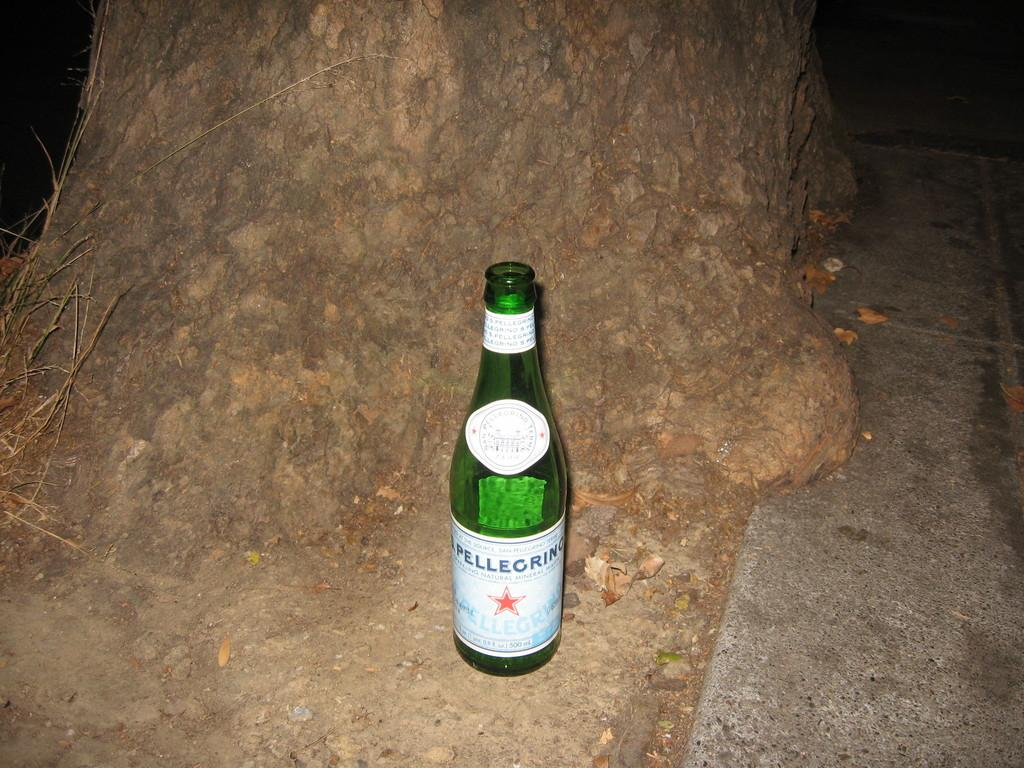What is the color of the bottle in the image? The bottle in the image is green. What is the bottle placed near in the image? The bottle is beside a stone. Is there a throne present in the image? No, there is no throne present in the image. Can you describe the existence of a seat in the image? There is no mention of a seat in the image, only a green bottle and a stone. 